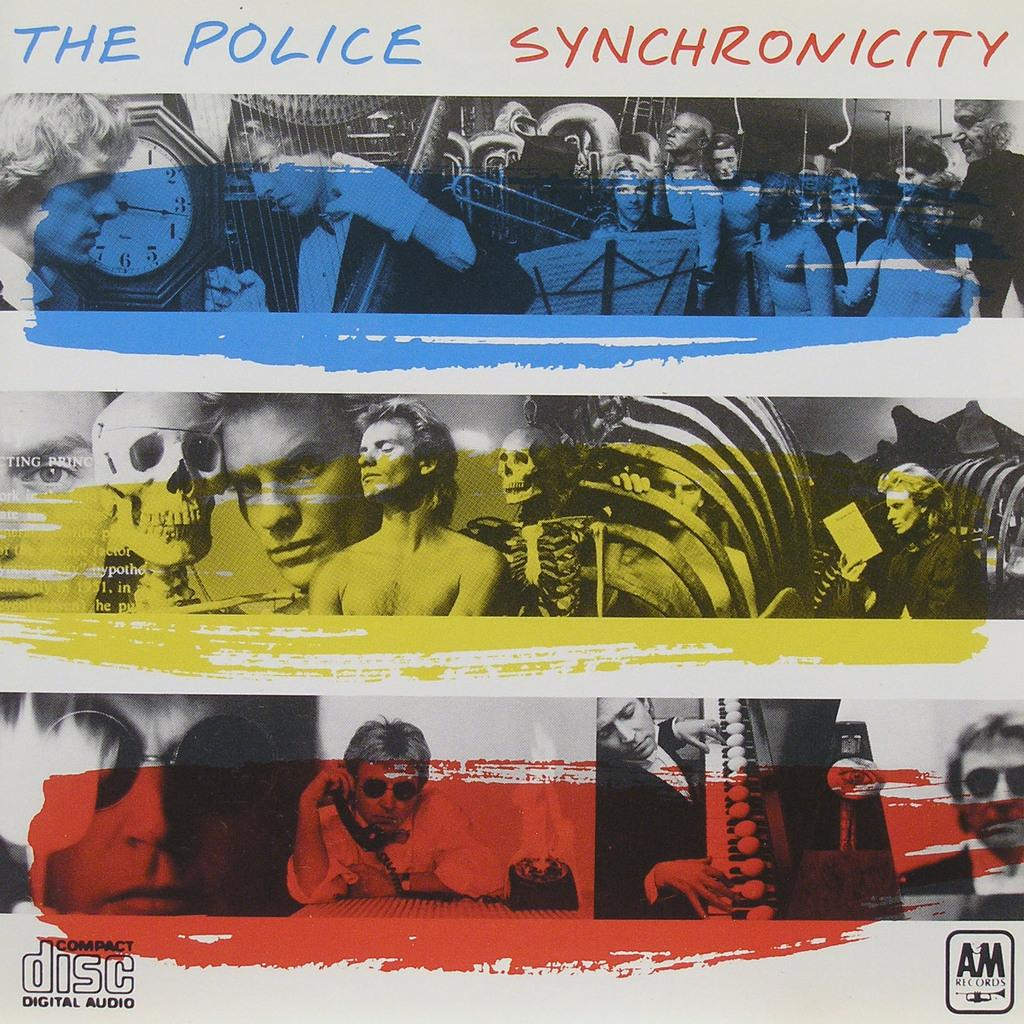Provide a one-sentence caption for the provided image. The Police Synchronicity is availble on a digital audio compact disc. 